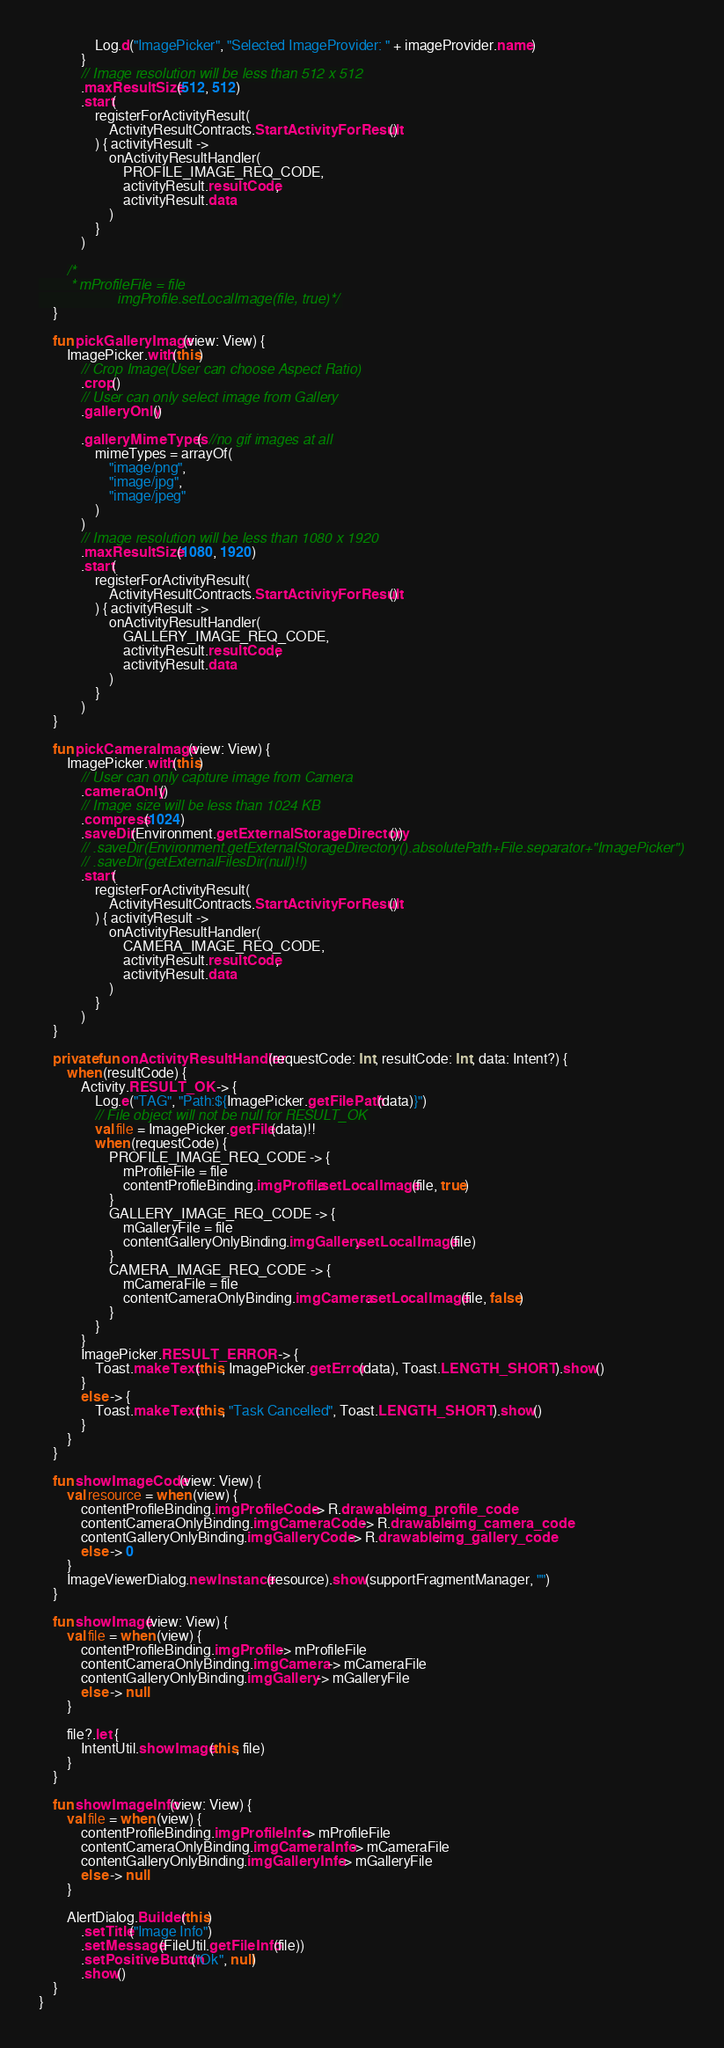<code> <loc_0><loc_0><loc_500><loc_500><_Kotlin_>                Log.d("ImagePicker", "Selected ImageProvider: " + imageProvider.name)
            }
            // Image resolution will be less than 512 x 512
            .maxResultSize(512, 512)
            .start(
                registerForActivityResult(
                    ActivityResultContracts.StartActivityForResult()
                ) { activityResult ->
                    onActivityResultHandler(
                        PROFILE_IMAGE_REQ_CODE,
                        activityResult.resultCode,
                        activityResult.data
                    )
                }
            )

        /*
        * mProfileFile = file
                    imgProfile.setLocalImage(file, true)*/
    }

    fun pickGalleryImage(view: View) {
        ImagePicker.with(this)
            // Crop Image(User can choose Aspect Ratio)
            .crop()
            // User can only select image from Gallery
            .galleryOnly()

            .galleryMimeTypes(  //no gif images at all
                mimeTypes = arrayOf(
                    "image/png",
                    "image/jpg",
                    "image/jpeg"
                )
            )
            // Image resolution will be less than 1080 x 1920
            .maxResultSize(1080, 1920)
            .start(
                registerForActivityResult(
                    ActivityResultContracts.StartActivityForResult()
                ) { activityResult ->
                    onActivityResultHandler(
                        GALLERY_IMAGE_REQ_CODE,
                        activityResult.resultCode,
                        activityResult.data
                    )
                }
            )
    }

    fun pickCameraImage(view: View) {
        ImagePicker.with(this)
            // User can only capture image from Camera
            .cameraOnly()
            // Image size will be less than 1024 KB
            .compress(1024)
            .saveDir(Environment.getExternalStorageDirectory())
            // .saveDir(Environment.getExternalStorageDirectory().absolutePath+File.separator+"ImagePicker")
            // .saveDir(getExternalFilesDir(null)!!)
            .start(
                registerForActivityResult(
                    ActivityResultContracts.StartActivityForResult()
                ) { activityResult ->
                    onActivityResultHandler(
                        CAMERA_IMAGE_REQ_CODE,
                        activityResult.resultCode,
                        activityResult.data
                    )
                }
            )
    }

    private fun onActivityResultHandler(requestCode: Int, resultCode: Int, data: Intent?) {
        when (resultCode) {
            Activity.RESULT_OK -> {
                Log.e("TAG", "Path:${ImagePicker.getFilePath(data)}")
                // File object will not be null for RESULT_OK
                val file = ImagePicker.getFile(data)!!
                when (requestCode) {
                    PROFILE_IMAGE_REQ_CODE -> {
                        mProfileFile = file
                        contentProfileBinding.imgProfile.setLocalImage(file, true)
                    }
                    GALLERY_IMAGE_REQ_CODE -> {
                        mGalleryFile = file
                        contentGalleryOnlyBinding.imgGallery.setLocalImage(file)
                    }
                    CAMERA_IMAGE_REQ_CODE -> {
                        mCameraFile = file
                        contentCameraOnlyBinding.imgCamera.setLocalImage(file, false)
                    }
                }
            }
            ImagePicker.RESULT_ERROR -> {
                Toast.makeText(this, ImagePicker.getError(data), Toast.LENGTH_SHORT).show()
            }
            else -> {
                Toast.makeText(this, "Task Cancelled", Toast.LENGTH_SHORT).show()
            }
        }
    }

    fun showImageCode(view: View) {
        val resource = when (view) {
            contentProfileBinding.imgProfileCode -> R.drawable.img_profile_code
            contentCameraOnlyBinding.imgCameraCode -> R.drawable.img_camera_code
            contentGalleryOnlyBinding.imgGalleryCode -> R.drawable.img_gallery_code
            else -> 0
        }
        ImageViewerDialog.newInstance(resource).show(supportFragmentManager, "")
    }

    fun showImage(view: View) {
        val file = when (view) {
            contentProfileBinding.imgProfile -> mProfileFile
            contentCameraOnlyBinding.imgCamera -> mCameraFile
            contentGalleryOnlyBinding.imgGallery -> mGalleryFile
            else -> null
        }

        file?.let {
            IntentUtil.showImage(this, file)
        }
    }

    fun showImageInfo(view: View) {
        val file = when (view) {
            contentProfileBinding.imgProfileInfo -> mProfileFile
            contentCameraOnlyBinding.imgCameraInfo -> mCameraFile
            contentGalleryOnlyBinding.imgGalleryInfo -> mGalleryFile
            else -> null
        }

        AlertDialog.Builder(this)
            .setTitle("Image Info")
            .setMessage(FileUtil.getFileInfo(file))
            .setPositiveButton("Ok", null)
            .show()
    }
}
</code> 